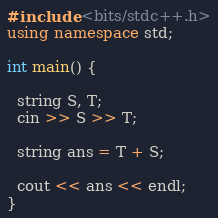Convert code to text. <code><loc_0><loc_0><loc_500><loc_500><_C++_>#include <bits/stdc++.h>
using namespace std;

int main() {
  
  string S, T;
  cin >> S >> T;
  
  string ans = T + S;
  
  cout << ans << endl;
}</code> 